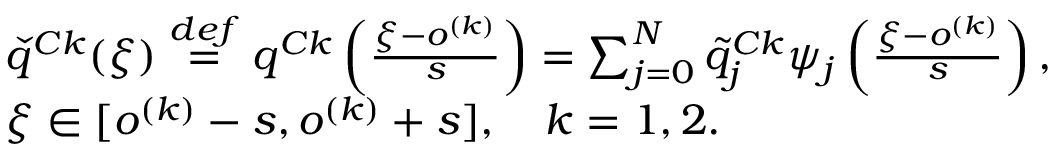<formula> <loc_0><loc_0><loc_500><loc_500>\begin{array} { r l } & { \check { q } ^ { C k } ( \xi ) \overset { d e f } { = } q ^ { C k } \left ( \frac { \xi - o ^ { ( k ) } } { s } \right ) = \sum _ { j = 0 } ^ { N } \tilde { q } _ { j } ^ { C k } \psi _ { j } \left ( \frac { \xi - o ^ { ( k ) } } { s } \right ) , } \\ & { \xi \in [ o ^ { ( k ) } - s , o ^ { ( k ) } + s ] , \quad k = 1 , 2 . } \end{array}</formula> 